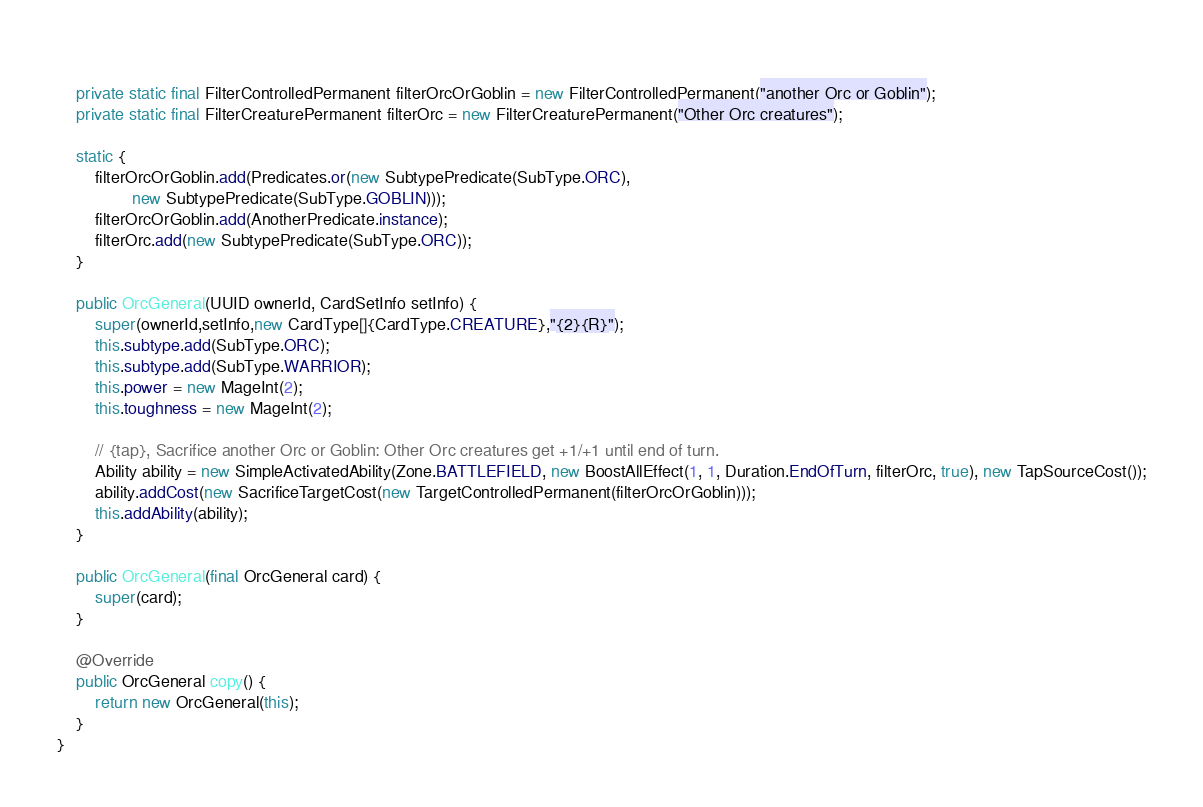Convert code to text. <code><loc_0><loc_0><loc_500><loc_500><_Java_>    
    private static final FilterControlledPermanent filterOrcOrGoblin = new FilterControlledPermanent("another Orc or Goblin");
    private static final FilterCreaturePermanent filterOrc = new FilterCreaturePermanent("Other Orc creatures");
    
    static {
        filterOrcOrGoblin.add(Predicates.or(new SubtypePredicate(SubType.ORC),
                new SubtypePredicate(SubType.GOBLIN)));
        filterOrcOrGoblin.add(AnotherPredicate.instance);
        filterOrc.add(new SubtypePredicate(SubType.ORC));
    }

    public OrcGeneral(UUID ownerId, CardSetInfo setInfo) {
        super(ownerId,setInfo,new CardType[]{CardType.CREATURE},"{2}{R}");
        this.subtype.add(SubType.ORC);
        this.subtype.add(SubType.WARRIOR);
        this.power = new MageInt(2);
        this.toughness = new MageInt(2);

        // {tap}, Sacrifice another Orc or Goblin: Other Orc creatures get +1/+1 until end of turn.
        Ability ability = new SimpleActivatedAbility(Zone.BATTLEFIELD, new BoostAllEffect(1, 1, Duration.EndOfTurn, filterOrc, true), new TapSourceCost());
        ability.addCost(new SacrificeTargetCost(new TargetControlledPermanent(filterOrcOrGoblin)));
        this.addAbility(ability);
    }

    public OrcGeneral(final OrcGeneral card) {
        super(card);
    }

    @Override
    public OrcGeneral copy() {
        return new OrcGeneral(this);
    }
}
</code> 